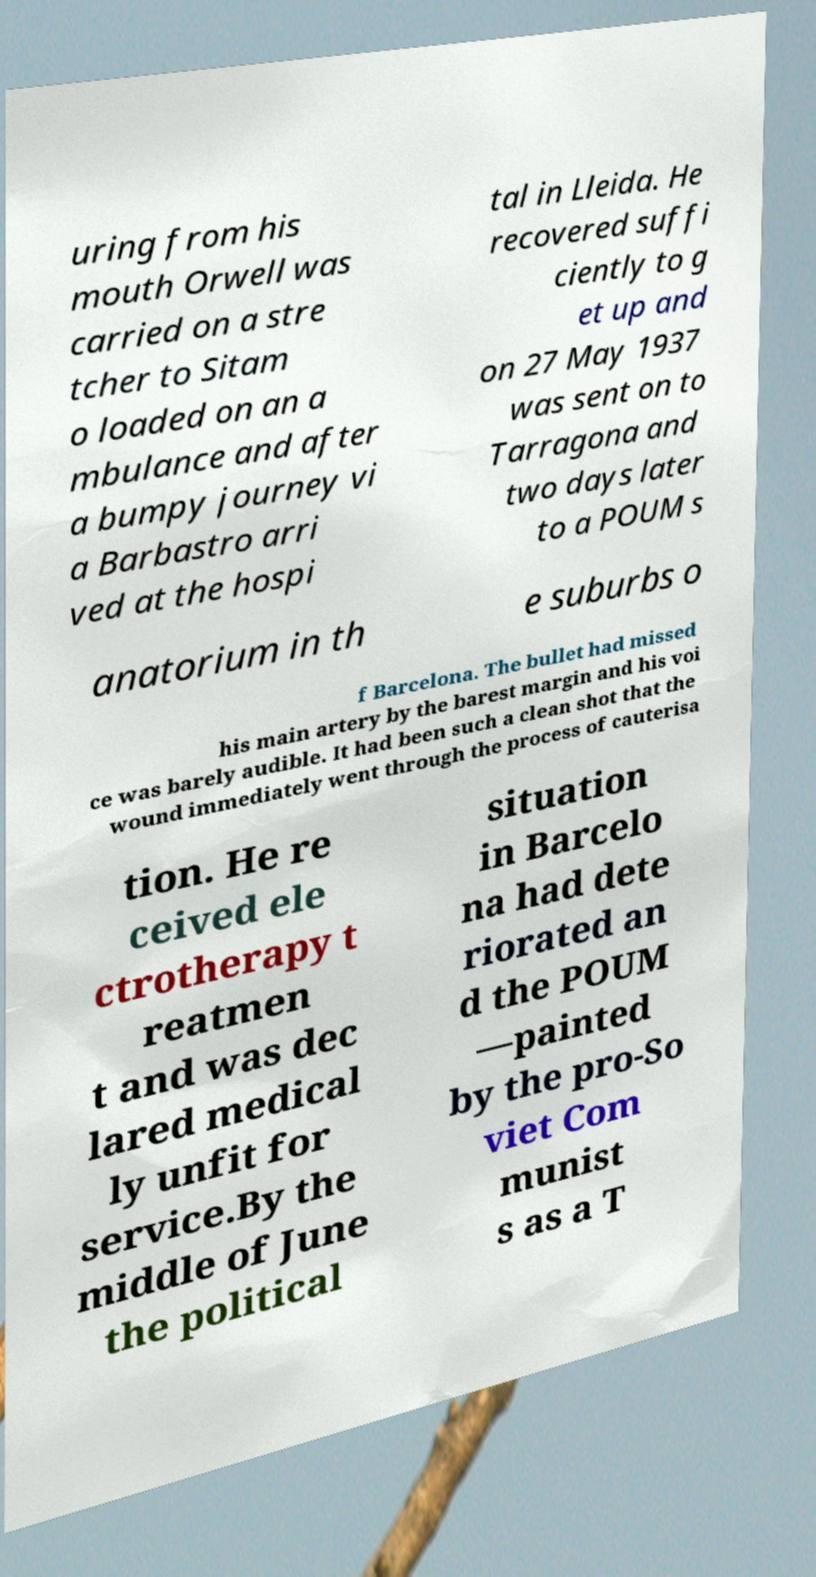Please identify and transcribe the text found in this image. uring from his mouth Orwell was carried on a stre tcher to Sitam o loaded on an a mbulance and after a bumpy journey vi a Barbastro arri ved at the hospi tal in Lleida. He recovered suffi ciently to g et up and on 27 May 1937 was sent on to Tarragona and two days later to a POUM s anatorium in th e suburbs o f Barcelona. The bullet had missed his main artery by the barest margin and his voi ce was barely audible. It had been such a clean shot that the wound immediately went through the process of cauterisa tion. He re ceived ele ctrotherapy t reatmen t and was dec lared medical ly unfit for service.By the middle of June the political situation in Barcelo na had dete riorated an d the POUM —painted by the pro-So viet Com munist s as a T 